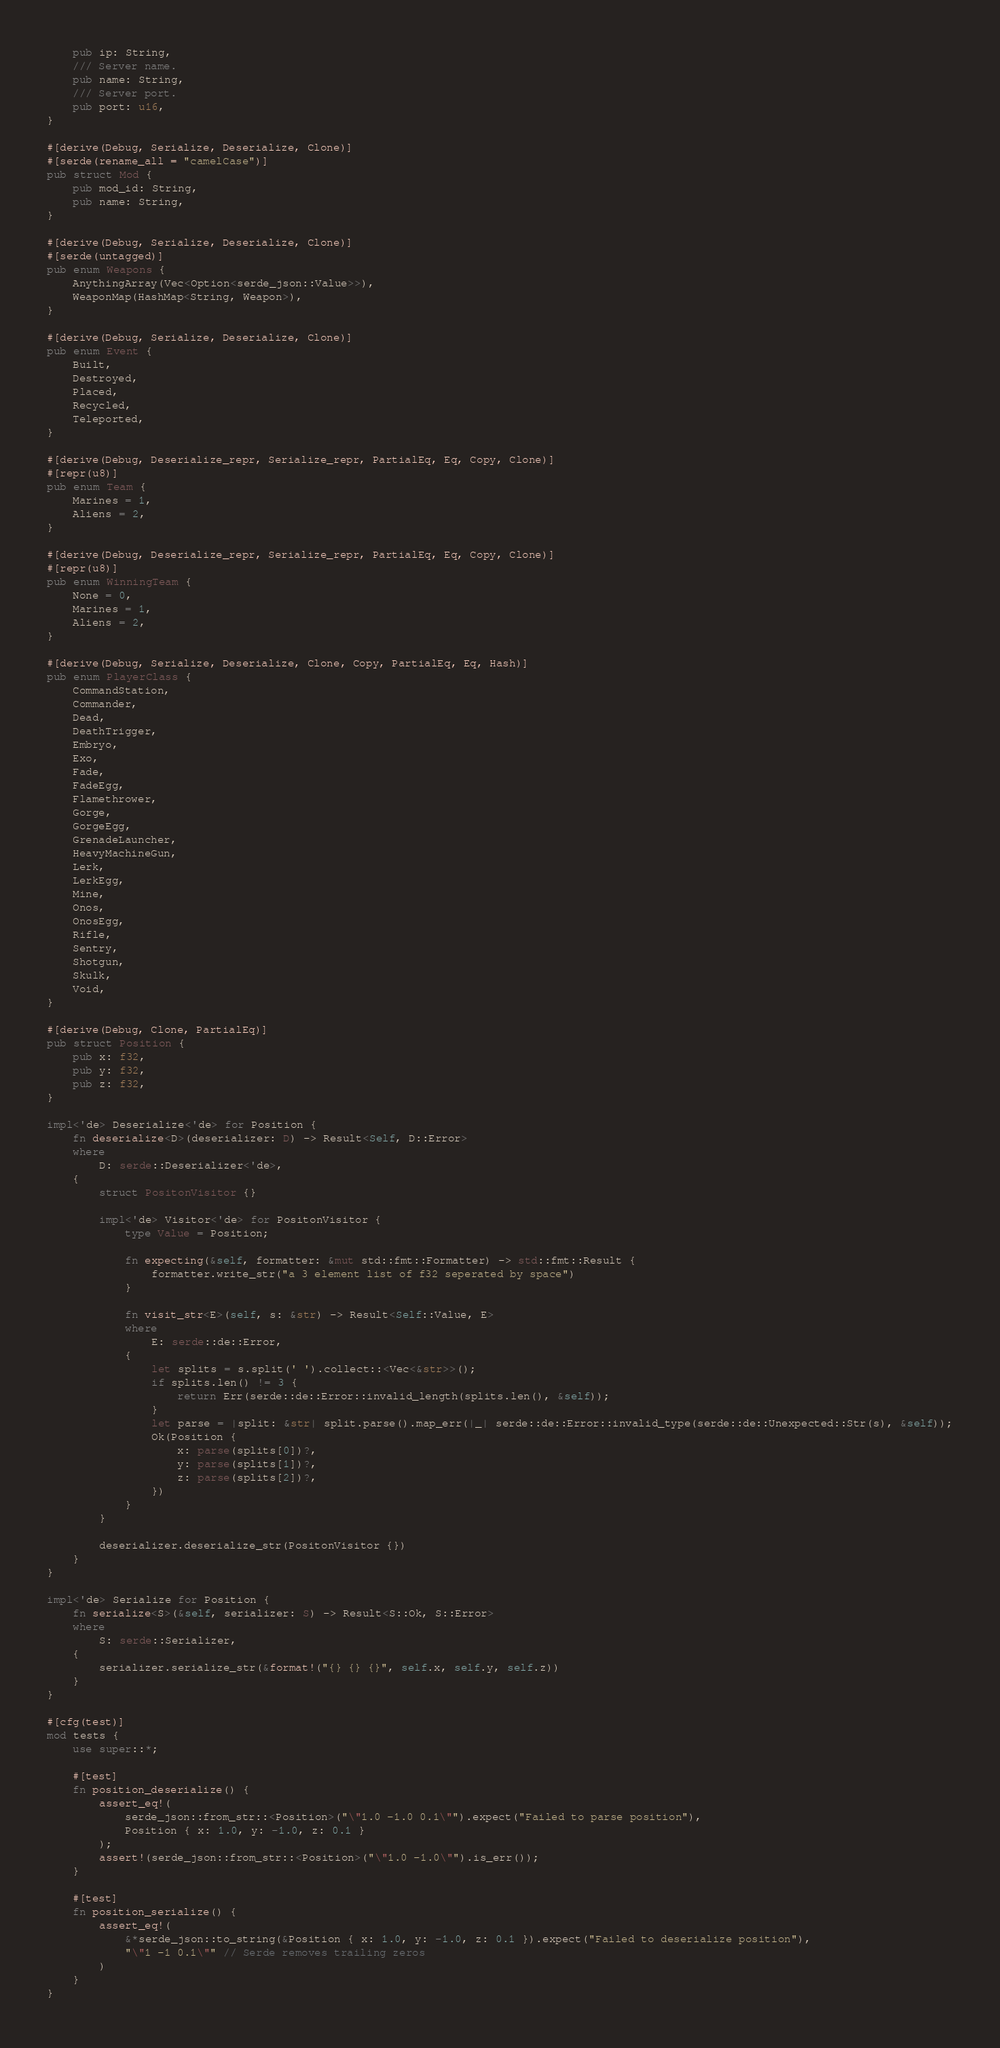Convert code to text. <code><loc_0><loc_0><loc_500><loc_500><_Rust_>    pub ip: String,
    /// Server name.
    pub name: String,
    /// Server port.
    pub port: u16,
}

#[derive(Debug, Serialize, Deserialize, Clone)]
#[serde(rename_all = "camelCase")]
pub struct Mod {
    pub mod_id: String,
    pub name: String,
}

#[derive(Debug, Serialize, Deserialize, Clone)]
#[serde(untagged)]
pub enum Weapons {
    AnythingArray(Vec<Option<serde_json::Value>>),
    WeaponMap(HashMap<String, Weapon>),
}

#[derive(Debug, Serialize, Deserialize, Clone)]
pub enum Event {
    Built,
    Destroyed,
    Placed,
    Recycled,
    Teleported,
}

#[derive(Debug, Deserialize_repr, Serialize_repr, PartialEq, Eq, Copy, Clone)]
#[repr(u8)]
pub enum Team {
    Marines = 1,
    Aliens = 2,
}

#[derive(Debug, Deserialize_repr, Serialize_repr, PartialEq, Eq, Copy, Clone)]
#[repr(u8)]
pub enum WinningTeam {
    None = 0,
    Marines = 1,
    Aliens = 2,
}

#[derive(Debug, Serialize, Deserialize, Clone, Copy, PartialEq, Eq, Hash)]
pub enum PlayerClass {
    CommandStation,
    Commander,
    Dead,
    DeathTrigger,
    Embryo,
    Exo,
    Fade,
    FadeEgg,
    Flamethrower,
    Gorge,
    GorgeEgg,
    GrenadeLauncher,
    HeavyMachineGun,
    Lerk,
    LerkEgg,
    Mine,
    Onos,
    OnosEgg,
    Rifle,
    Sentry,
    Shotgun,
    Skulk,
    Void,
}

#[derive(Debug, Clone, PartialEq)]
pub struct Position {
    pub x: f32,
    pub y: f32,
    pub z: f32,
}

impl<'de> Deserialize<'de> for Position {
    fn deserialize<D>(deserializer: D) -> Result<Self, D::Error>
    where
        D: serde::Deserializer<'de>,
    {
        struct PositonVisitor {}

        impl<'de> Visitor<'de> for PositonVisitor {
            type Value = Position;

            fn expecting(&self, formatter: &mut std::fmt::Formatter) -> std::fmt::Result {
                formatter.write_str("a 3 element list of f32 seperated by space")
            }

            fn visit_str<E>(self, s: &str) -> Result<Self::Value, E>
            where
                E: serde::de::Error,
            {
                let splits = s.split(' ').collect::<Vec<&str>>();
                if splits.len() != 3 {
                    return Err(serde::de::Error::invalid_length(splits.len(), &self));
                }
                let parse = |split: &str| split.parse().map_err(|_| serde::de::Error::invalid_type(serde::de::Unexpected::Str(s), &self));
                Ok(Position {
                    x: parse(splits[0])?,
                    y: parse(splits[1])?,
                    z: parse(splits[2])?,
                })
            }
        }

        deserializer.deserialize_str(PositonVisitor {})
    }
}

impl<'de> Serialize for Position {
    fn serialize<S>(&self, serializer: S) -> Result<S::Ok, S::Error>
    where
        S: serde::Serializer,
    {
        serializer.serialize_str(&format!("{} {} {}", self.x, self.y, self.z))
    }
}

#[cfg(test)]
mod tests {
    use super::*;

    #[test]
    fn position_deserialize() {
        assert_eq!(
            serde_json::from_str::<Position>("\"1.0 -1.0 0.1\"").expect("Failed to parse position"),
            Position { x: 1.0, y: -1.0, z: 0.1 }
        );
        assert!(serde_json::from_str::<Position>("\"1.0 -1.0\"").is_err());
    }

    #[test]
    fn position_serialize() {
        assert_eq!(
            &*serde_json::to_string(&Position { x: 1.0, y: -1.0, z: 0.1 }).expect("Failed to deserialize position"),
            "\"1 -1 0.1\"" // Serde removes trailing zeros
        )
    }
}
</code> 